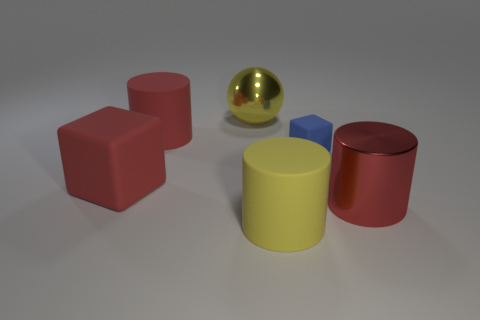Is there any other thing that is the same size as the blue rubber thing?
Provide a succinct answer. No. What is the shape of the metal thing that is the same color as the large cube?
Your answer should be compact. Cylinder. There is a large thing that is the same shape as the small blue object; what color is it?
Offer a very short reply. Red. How many yellow things are large cylinders or small objects?
Offer a terse response. 1. The large red cylinder that is left of the yellow thing that is right of the large yellow shiny object is made of what material?
Your response must be concise. Rubber. Do the tiny matte thing and the big yellow rubber thing have the same shape?
Ensure brevity in your answer.  No. The ball that is the same size as the yellow matte cylinder is what color?
Your response must be concise. Yellow. Is there a large rubber cylinder of the same color as the sphere?
Give a very brief answer. Yes. Is there a large yellow cylinder?
Offer a very short reply. Yes. Does the red object behind the small matte object have the same material as the small blue cube?
Ensure brevity in your answer.  Yes. 